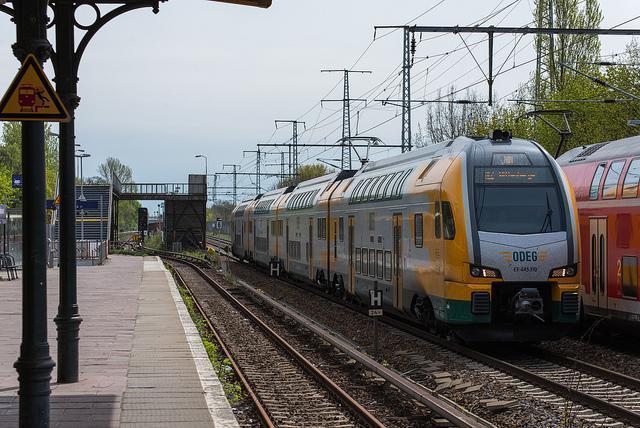What number is on the red train?
Pick the right solution, then justify: 'Answer: answer
Rationale: rationale.'
Options: Nine, six, one, two. Answer: two.
Rationale: The number is 2. 